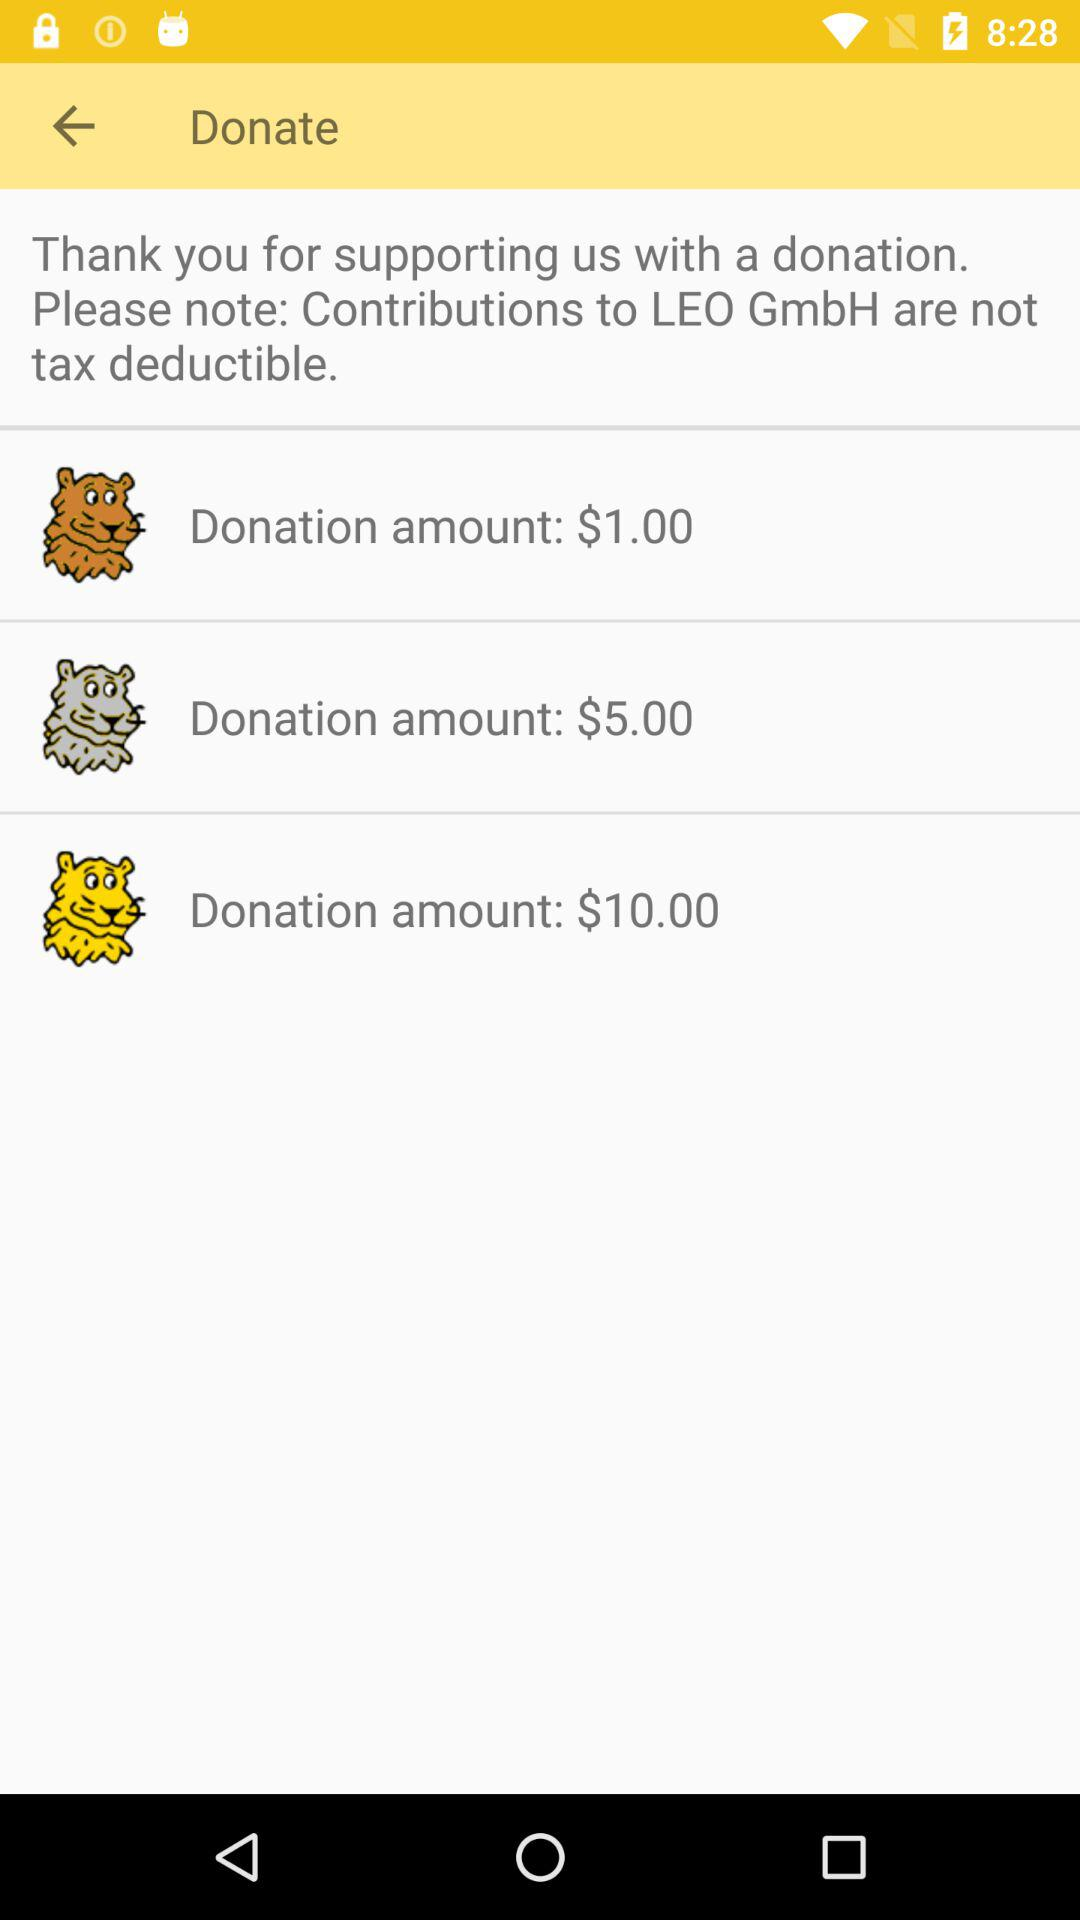How many donation amounts are there?
Answer the question using a single word or phrase. 3 